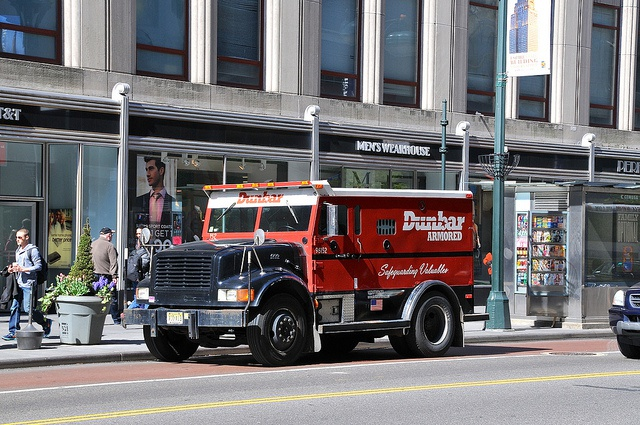Describe the objects in this image and their specific colors. I can see truck in darkblue, black, maroon, gray, and darkgray tones, potted plant in darkblue, black, lightgray, darkgray, and gray tones, people in darkblue, black, gray, and darkgray tones, people in darkblue, black, white, darkgray, and navy tones, and car in darkblue, black, gray, navy, and darkgray tones in this image. 